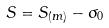Convert formula to latex. <formula><loc_0><loc_0><loc_500><loc_500>S = S _ { ( m ) } - \sigma _ { 0 }</formula> 